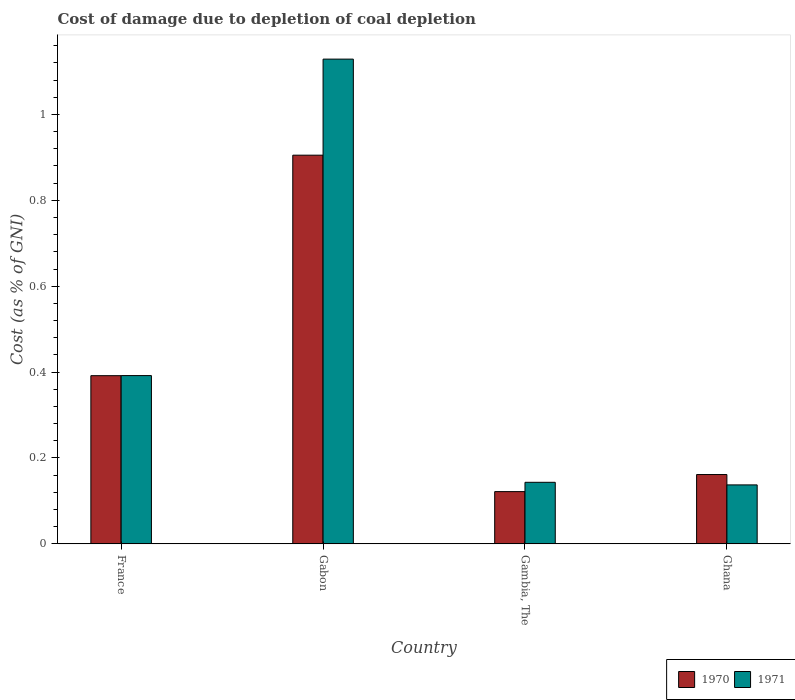How many different coloured bars are there?
Your answer should be compact. 2. Are the number of bars per tick equal to the number of legend labels?
Your response must be concise. Yes. Are the number of bars on each tick of the X-axis equal?
Keep it short and to the point. Yes. What is the label of the 2nd group of bars from the left?
Offer a very short reply. Gabon. What is the cost of damage caused due to coal depletion in 1971 in France?
Make the answer very short. 0.39. Across all countries, what is the maximum cost of damage caused due to coal depletion in 1971?
Make the answer very short. 1.13. Across all countries, what is the minimum cost of damage caused due to coal depletion in 1970?
Provide a succinct answer. 0.12. In which country was the cost of damage caused due to coal depletion in 1970 maximum?
Keep it short and to the point. Gabon. What is the total cost of damage caused due to coal depletion in 1971 in the graph?
Offer a very short reply. 1.8. What is the difference between the cost of damage caused due to coal depletion in 1970 in Gambia, The and that in Ghana?
Your answer should be very brief. -0.04. What is the difference between the cost of damage caused due to coal depletion in 1971 in Gabon and the cost of damage caused due to coal depletion in 1970 in Gambia, The?
Give a very brief answer. 1.01. What is the average cost of damage caused due to coal depletion in 1970 per country?
Ensure brevity in your answer.  0.39. What is the difference between the cost of damage caused due to coal depletion of/in 1970 and cost of damage caused due to coal depletion of/in 1971 in Ghana?
Your answer should be compact. 0.02. In how many countries, is the cost of damage caused due to coal depletion in 1971 greater than 0.16 %?
Your answer should be compact. 2. What is the ratio of the cost of damage caused due to coal depletion in 1970 in Gabon to that in Gambia, The?
Your answer should be very brief. 7.44. Is the cost of damage caused due to coal depletion in 1970 in France less than that in Gambia, The?
Your response must be concise. No. What is the difference between the highest and the second highest cost of damage caused due to coal depletion in 1971?
Provide a succinct answer. -0.74. What is the difference between the highest and the lowest cost of damage caused due to coal depletion in 1971?
Provide a succinct answer. 0.99. In how many countries, is the cost of damage caused due to coal depletion in 1970 greater than the average cost of damage caused due to coal depletion in 1970 taken over all countries?
Offer a terse response. 1. Are all the bars in the graph horizontal?
Your answer should be compact. No. How many countries are there in the graph?
Offer a very short reply. 4. Are the values on the major ticks of Y-axis written in scientific E-notation?
Provide a short and direct response. No. Does the graph contain any zero values?
Provide a succinct answer. No. Does the graph contain grids?
Provide a short and direct response. No. Where does the legend appear in the graph?
Your answer should be very brief. Bottom right. How are the legend labels stacked?
Give a very brief answer. Horizontal. What is the title of the graph?
Provide a short and direct response. Cost of damage due to depletion of coal depletion. Does "2006" appear as one of the legend labels in the graph?
Provide a succinct answer. No. What is the label or title of the Y-axis?
Provide a succinct answer. Cost (as % of GNI). What is the Cost (as % of GNI) in 1970 in France?
Give a very brief answer. 0.39. What is the Cost (as % of GNI) in 1971 in France?
Ensure brevity in your answer.  0.39. What is the Cost (as % of GNI) in 1970 in Gabon?
Provide a short and direct response. 0.91. What is the Cost (as % of GNI) in 1971 in Gabon?
Your answer should be compact. 1.13. What is the Cost (as % of GNI) of 1970 in Gambia, The?
Your answer should be very brief. 0.12. What is the Cost (as % of GNI) in 1971 in Gambia, The?
Ensure brevity in your answer.  0.14. What is the Cost (as % of GNI) in 1970 in Ghana?
Make the answer very short. 0.16. What is the Cost (as % of GNI) in 1971 in Ghana?
Keep it short and to the point. 0.14. Across all countries, what is the maximum Cost (as % of GNI) in 1970?
Your answer should be compact. 0.91. Across all countries, what is the maximum Cost (as % of GNI) of 1971?
Provide a succinct answer. 1.13. Across all countries, what is the minimum Cost (as % of GNI) in 1970?
Your response must be concise. 0.12. Across all countries, what is the minimum Cost (as % of GNI) of 1971?
Make the answer very short. 0.14. What is the total Cost (as % of GNI) of 1970 in the graph?
Give a very brief answer. 1.58. What is the total Cost (as % of GNI) of 1971 in the graph?
Offer a terse response. 1.8. What is the difference between the Cost (as % of GNI) in 1970 in France and that in Gabon?
Give a very brief answer. -0.51. What is the difference between the Cost (as % of GNI) of 1971 in France and that in Gabon?
Give a very brief answer. -0.74. What is the difference between the Cost (as % of GNI) in 1970 in France and that in Gambia, The?
Your answer should be very brief. 0.27. What is the difference between the Cost (as % of GNI) of 1971 in France and that in Gambia, The?
Give a very brief answer. 0.25. What is the difference between the Cost (as % of GNI) of 1970 in France and that in Ghana?
Make the answer very short. 0.23. What is the difference between the Cost (as % of GNI) of 1971 in France and that in Ghana?
Keep it short and to the point. 0.25. What is the difference between the Cost (as % of GNI) of 1970 in Gabon and that in Gambia, The?
Ensure brevity in your answer.  0.78. What is the difference between the Cost (as % of GNI) in 1971 in Gabon and that in Gambia, The?
Your answer should be compact. 0.99. What is the difference between the Cost (as % of GNI) of 1970 in Gabon and that in Ghana?
Your answer should be compact. 0.74. What is the difference between the Cost (as % of GNI) of 1970 in Gambia, The and that in Ghana?
Give a very brief answer. -0.04. What is the difference between the Cost (as % of GNI) of 1971 in Gambia, The and that in Ghana?
Make the answer very short. 0.01. What is the difference between the Cost (as % of GNI) of 1970 in France and the Cost (as % of GNI) of 1971 in Gabon?
Provide a succinct answer. -0.74. What is the difference between the Cost (as % of GNI) in 1970 in France and the Cost (as % of GNI) in 1971 in Gambia, The?
Keep it short and to the point. 0.25. What is the difference between the Cost (as % of GNI) of 1970 in France and the Cost (as % of GNI) of 1971 in Ghana?
Your response must be concise. 0.25. What is the difference between the Cost (as % of GNI) in 1970 in Gabon and the Cost (as % of GNI) in 1971 in Gambia, The?
Make the answer very short. 0.76. What is the difference between the Cost (as % of GNI) of 1970 in Gabon and the Cost (as % of GNI) of 1971 in Ghana?
Make the answer very short. 0.77. What is the difference between the Cost (as % of GNI) of 1970 in Gambia, The and the Cost (as % of GNI) of 1971 in Ghana?
Make the answer very short. -0.02. What is the average Cost (as % of GNI) in 1970 per country?
Ensure brevity in your answer.  0.4. What is the average Cost (as % of GNI) in 1971 per country?
Offer a terse response. 0.45. What is the difference between the Cost (as % of GNI) of 1970 and Cost (as % of GNI) of 1971 in France?
Keep it short and to the point. -0. What is the difference between the Cost (as % of GNI) of 1970 and Cost (as % of GNI) of 1971 in Gabon?
Ensure brevity in your answer.  -0.22. What is the difference between the Cost (as % of GNI) in 1970 and Cost (as % of GNI) in 1971 in Gambia, The?
Ensure brevity in your answer.  -0.02. What is the difference between the Cost (as % of GNI) of 1970 and Cost (as % of GNI) of 1971 in Ghana?
Your answer should be very brief. 0.02. What is the ratio of the Cost (as % of GNI) of 1970 in France to that in Gabon?
Your answer should be very brief. 0.43. What is the ratio of the Cost (as % of GNI) in 1971 in France to that in Gabon?
Give a very brief answer. 0.35. What is the ratio of the Cost (as % of GNI) of 1970 in France to that in Gambia, The?
Offer a very short reply. 3.22. What is the ratio of the Cost (as % of GNI) in 1971 in France to that in Gambia, The?
Provide a short and direct response. 2.73. What is the ratio of the Cost (as % of GNI) of 1970 in France to that in Ghana?
Make the answer very short. 2.43. What is the ratio of the Cost (as % of GNI) in 1971 in France to that in Ghana?
Your response must be concise. 2.85. What is the ratio of the Cost (as % of GNI) of 1970 in Gabon to that in Gambia, The?
Offer a very short reply. 7.44. What is the ratio of the Cost (as % of GNI) of 1971 in Gabon to that in Gambia, The?
Provide a short and direct response. 7.88. What is the ratio of the Cost (as % of GNI) in 1970 in Gabon to that in Ghana?
Ensure brevity in your answer.  5.61. What is the ratio of the Cost (as % of GNI) of 1971 in Gabon to that in Ghana?
Offer a very short reply. 8.22. What is the ratio of the Cost (as % of GNI) in 1970 in Gambia, The to that in Ghana?
Make the answer very short. 0.75. What is the ratio of the Cost (as % of GNI) in 1971 in Gambia, The to that in Ghana?
Your answer should be very brief. 1.04. What is the difference between the highest and the second highest Cost (as % of GNI) in 1970?
Your response must be concise. 0.51. What is the difference between the highest and the second highest Cost (as % of GNI) in 1971?
Your answer should be very brief. 0.74. What is the difference between the highest and the lowest Cost (as % of GNI) in 1970?
Offer a terse response. 0.78. What is the difference between the highest and the lowest Cost (as % of GNI) of 1971?
Offer a terse response. 0.99. 